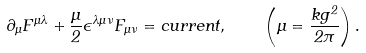Convert formula to latex. <formula><loc_0><loc_0><loc_500><loc_500>\partial _ { \mu } F ^ { \mu \lambda } + \frac { \mu } { 2 } \epsilon ^ { \lambda \mu \nu } F _ { \mu \nu } = c u r r e n t , \quad \left ( \mu = \frac { k g ^ { 2 } } { 2 \pi } \right ) .</formula> 